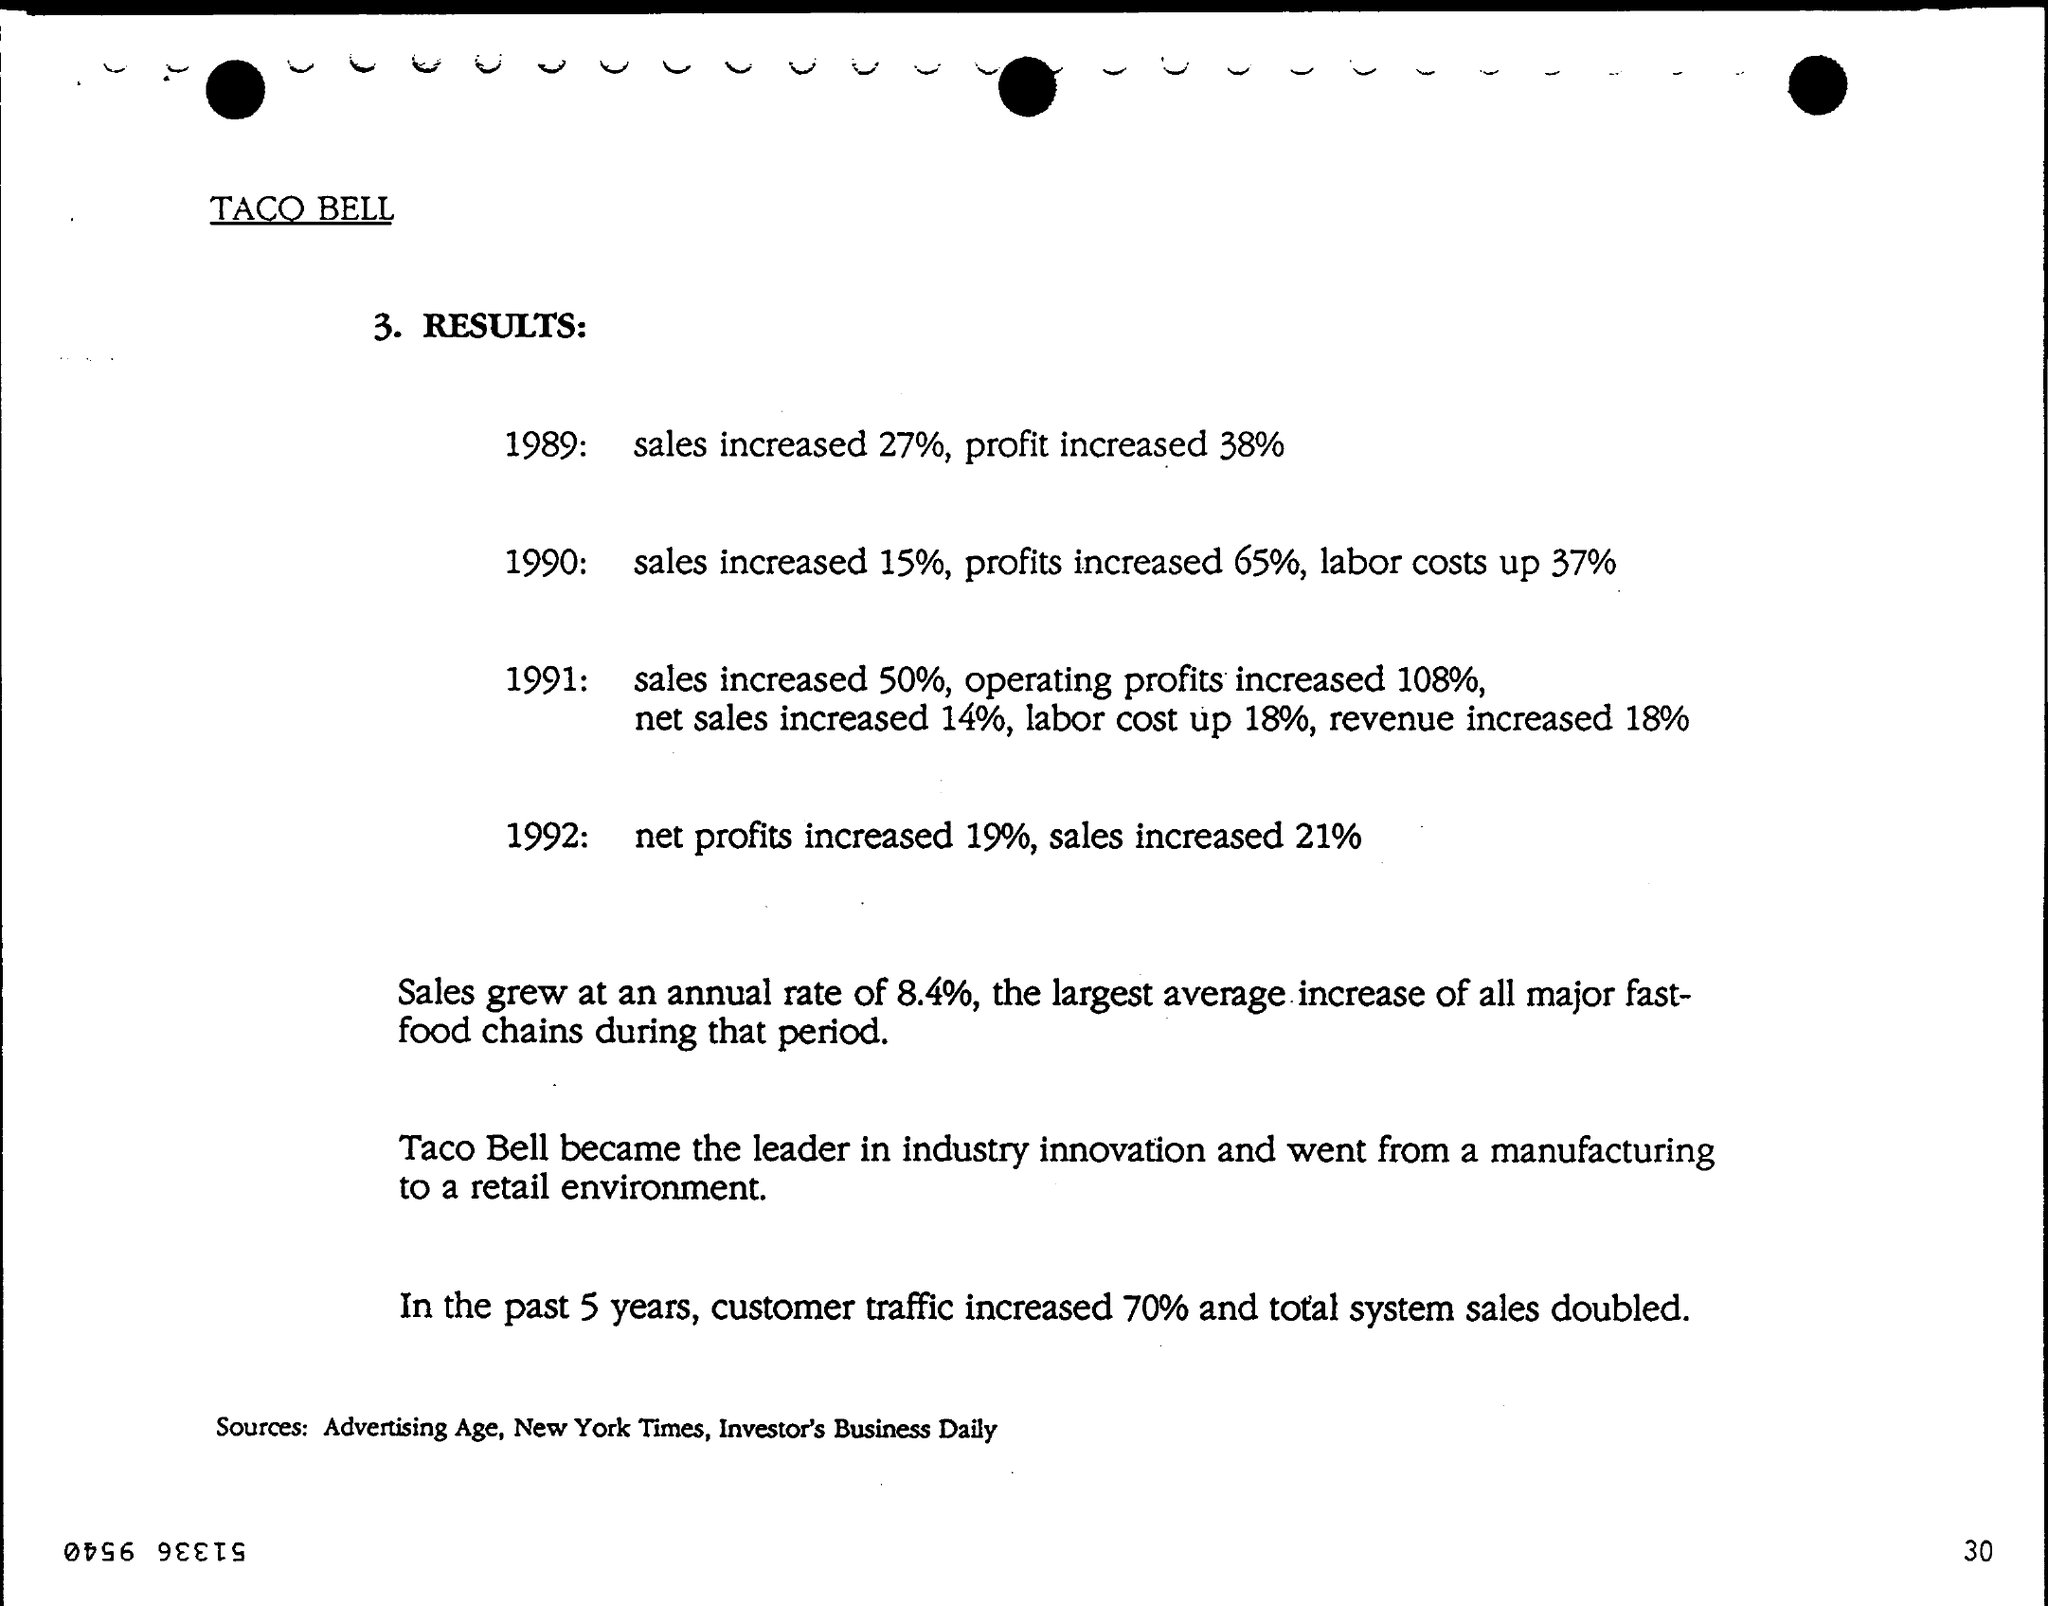List a handful of essential elements in this visual. In 1989, the sales increased by 27%. Taco Bell is recognized as the leader in industry innovation. The net profits increased by 19% in 1992. In the past 5 years, there has been a significant increase in customer traffic, with an increase of 70%. The labour cost increased by 18% in 1991. 